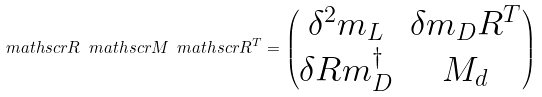<formula> <loc_0><loc_0><loc_500><loc_500>\ m a t h s c r { R } \ m a t h s c r { M } \ m a t h s c r { R } ^ { T } = \begin{pmatrix} \delta ^ { 2 } m _ { L } & \delta m _ { D } R ^ { T } \\ \delta R m _ { D } ^ { \dagger } & M _ { d } \end{pmatrix}</formula> 